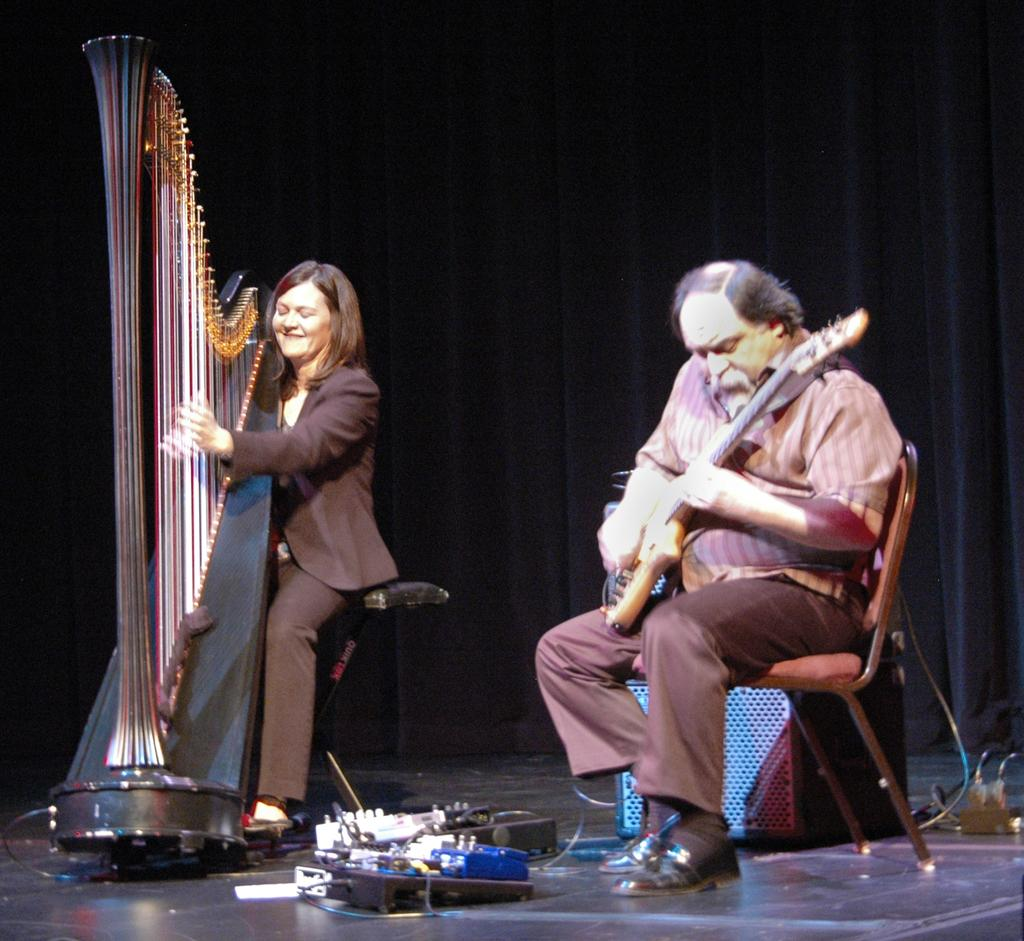How many people are in the image? There are two people in the image. What are the people doing in the image? The two people are sitting on a dais and playing musical instruments. What can be seen in the background of the image? There is a black curtain in the background of the image. Can you tell me where the father of the people in the image is sitting? There is no information about the people's father in the image, nor is there any indication of where he might be sitting. 